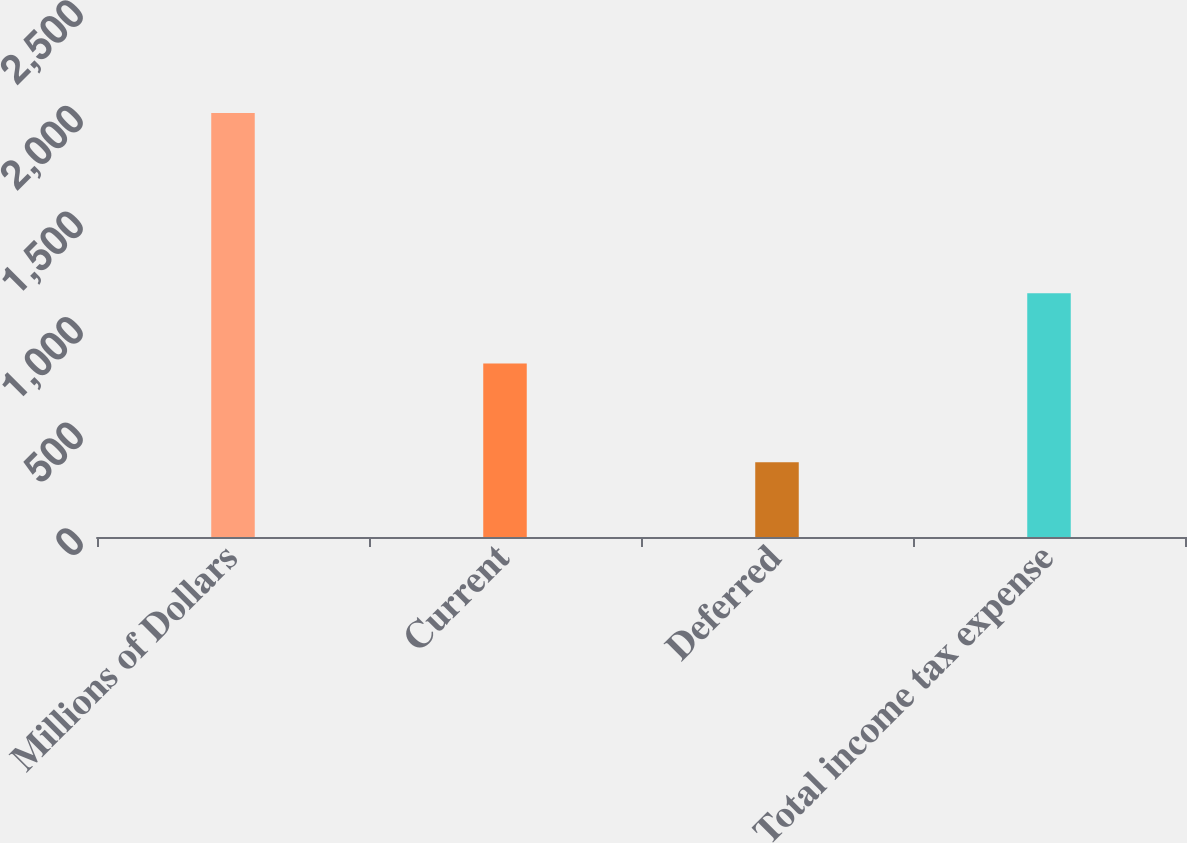Convert chart. <chart><loc_0><loc_0><loc_500><loc_500><bar_chart><fcel>Millions of Dollars<fcel>Current<fcel>Deferred<fcel>Total income tax expense<nl><fcel>2007<fcel>822<fcel>354<fcel>1154<nl></chart> 